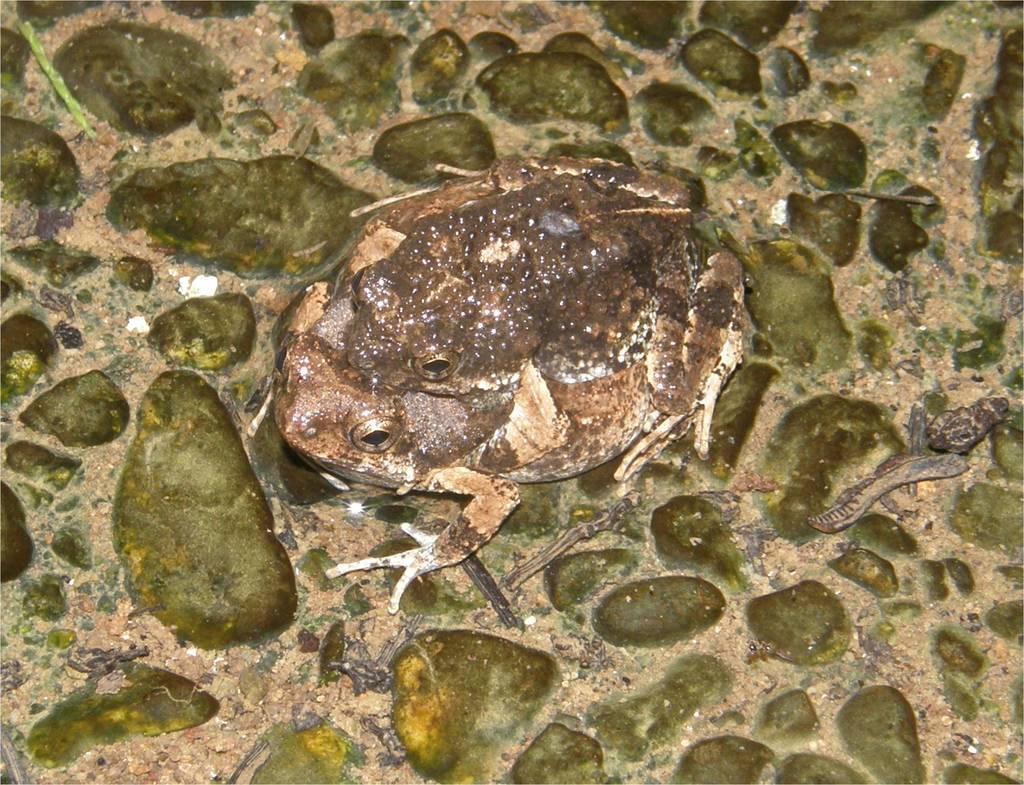Please provide a concise description of this image. In the center of the image there is a frog on the surface. 